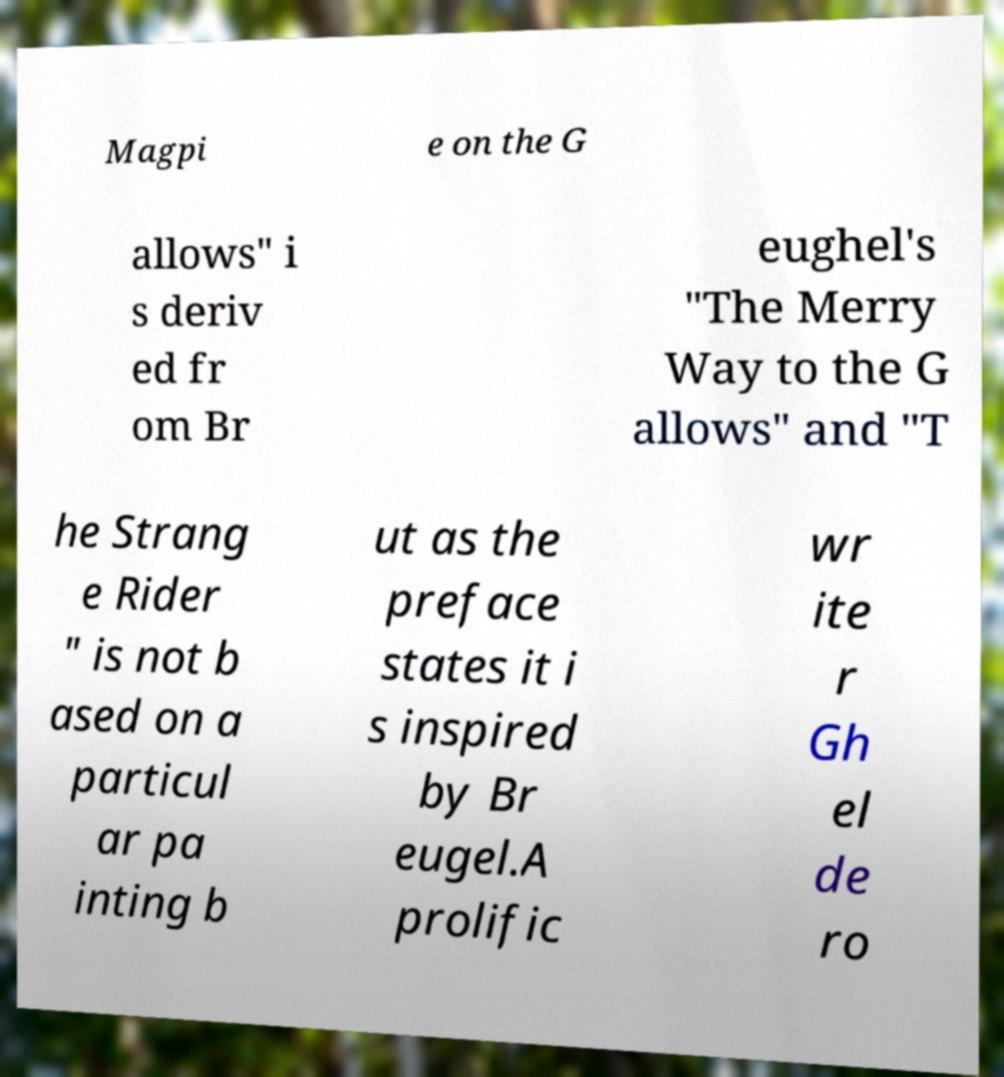There's text embedded in this image that I need extracted. Can you transcribe it verbatim? Magpi e on the G allows" i s deriv ed fr om Br eughel's "The Merry Way to the G allows" and "T he Strang e Rider " is not b ased on a particul ar pa inting b ut as the preface states it i s inspired by Br eugel.A prolific wr ite r Gh el de ro 